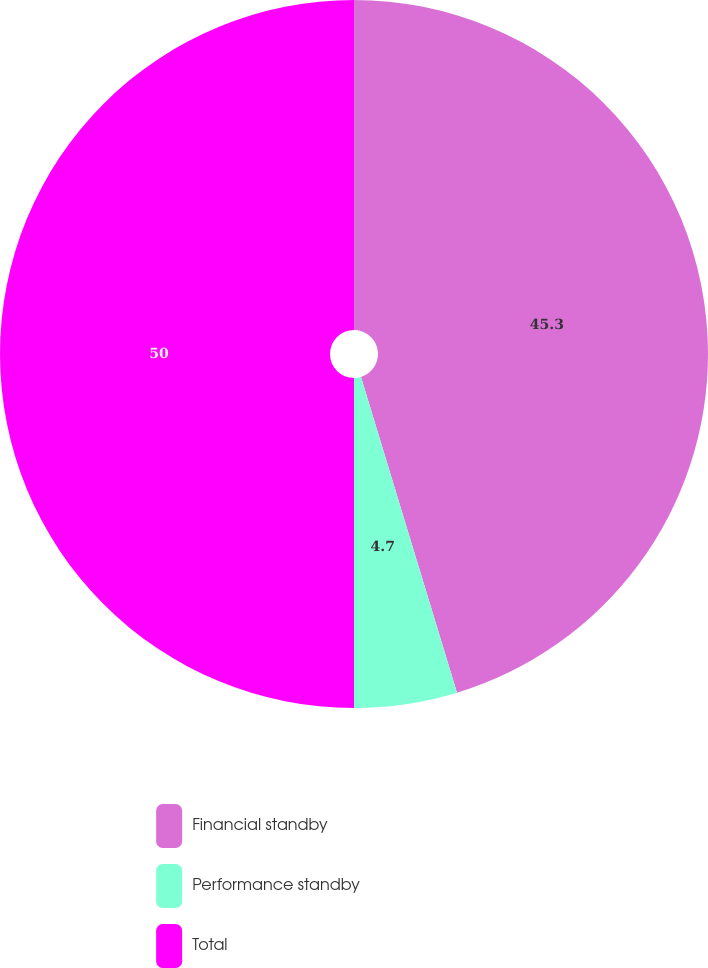Convert chart to OTSL. <chart><loc_0><loc_0><loc_500><loc_500><pie_chart><fcel>Financial standby<fcel>Performance standby<fcel>Total<nl><fcel>45.3%<fcel>4.7%<fcel>50.0%<nl></chart> 